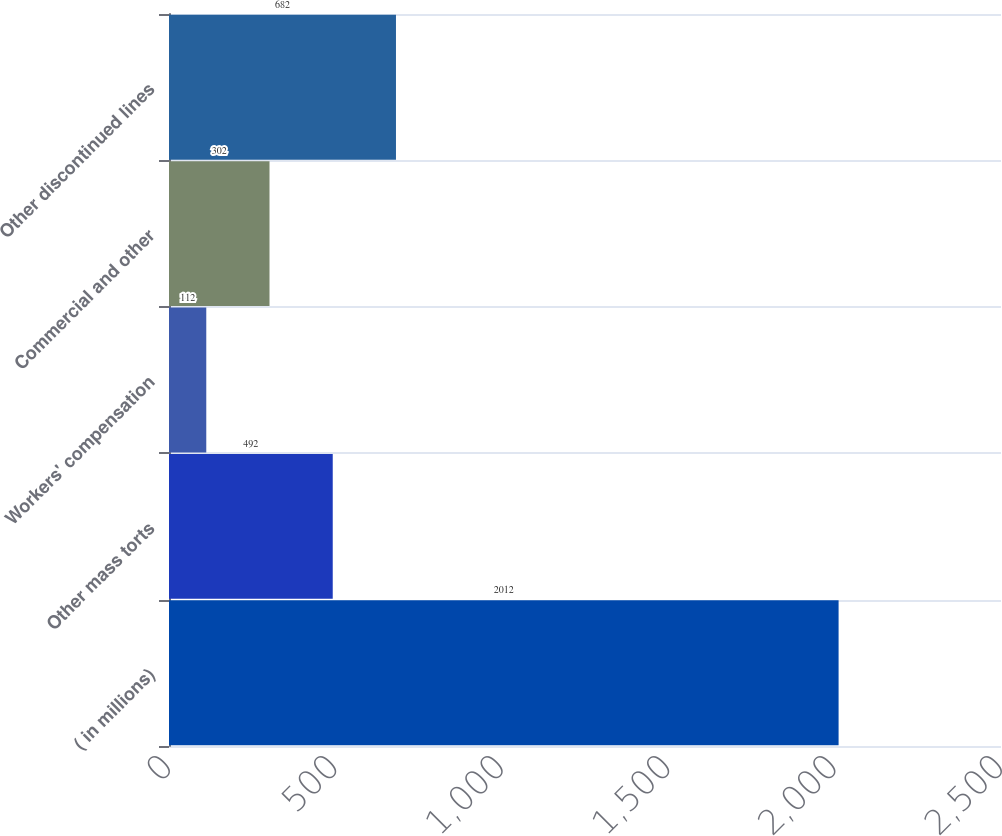<chart> <loc_0><loc_0><loc_500><loc_500><bar_chart><fcel>( in millions)<fcel>Other mass torts<fcel>Workers' compensation<fcel>Commercial and other<fcel>Other discontinued lines<nl><fcel>2012<fcel>492<fcel>112<fcel>302<fcel>682<nl></chart> 